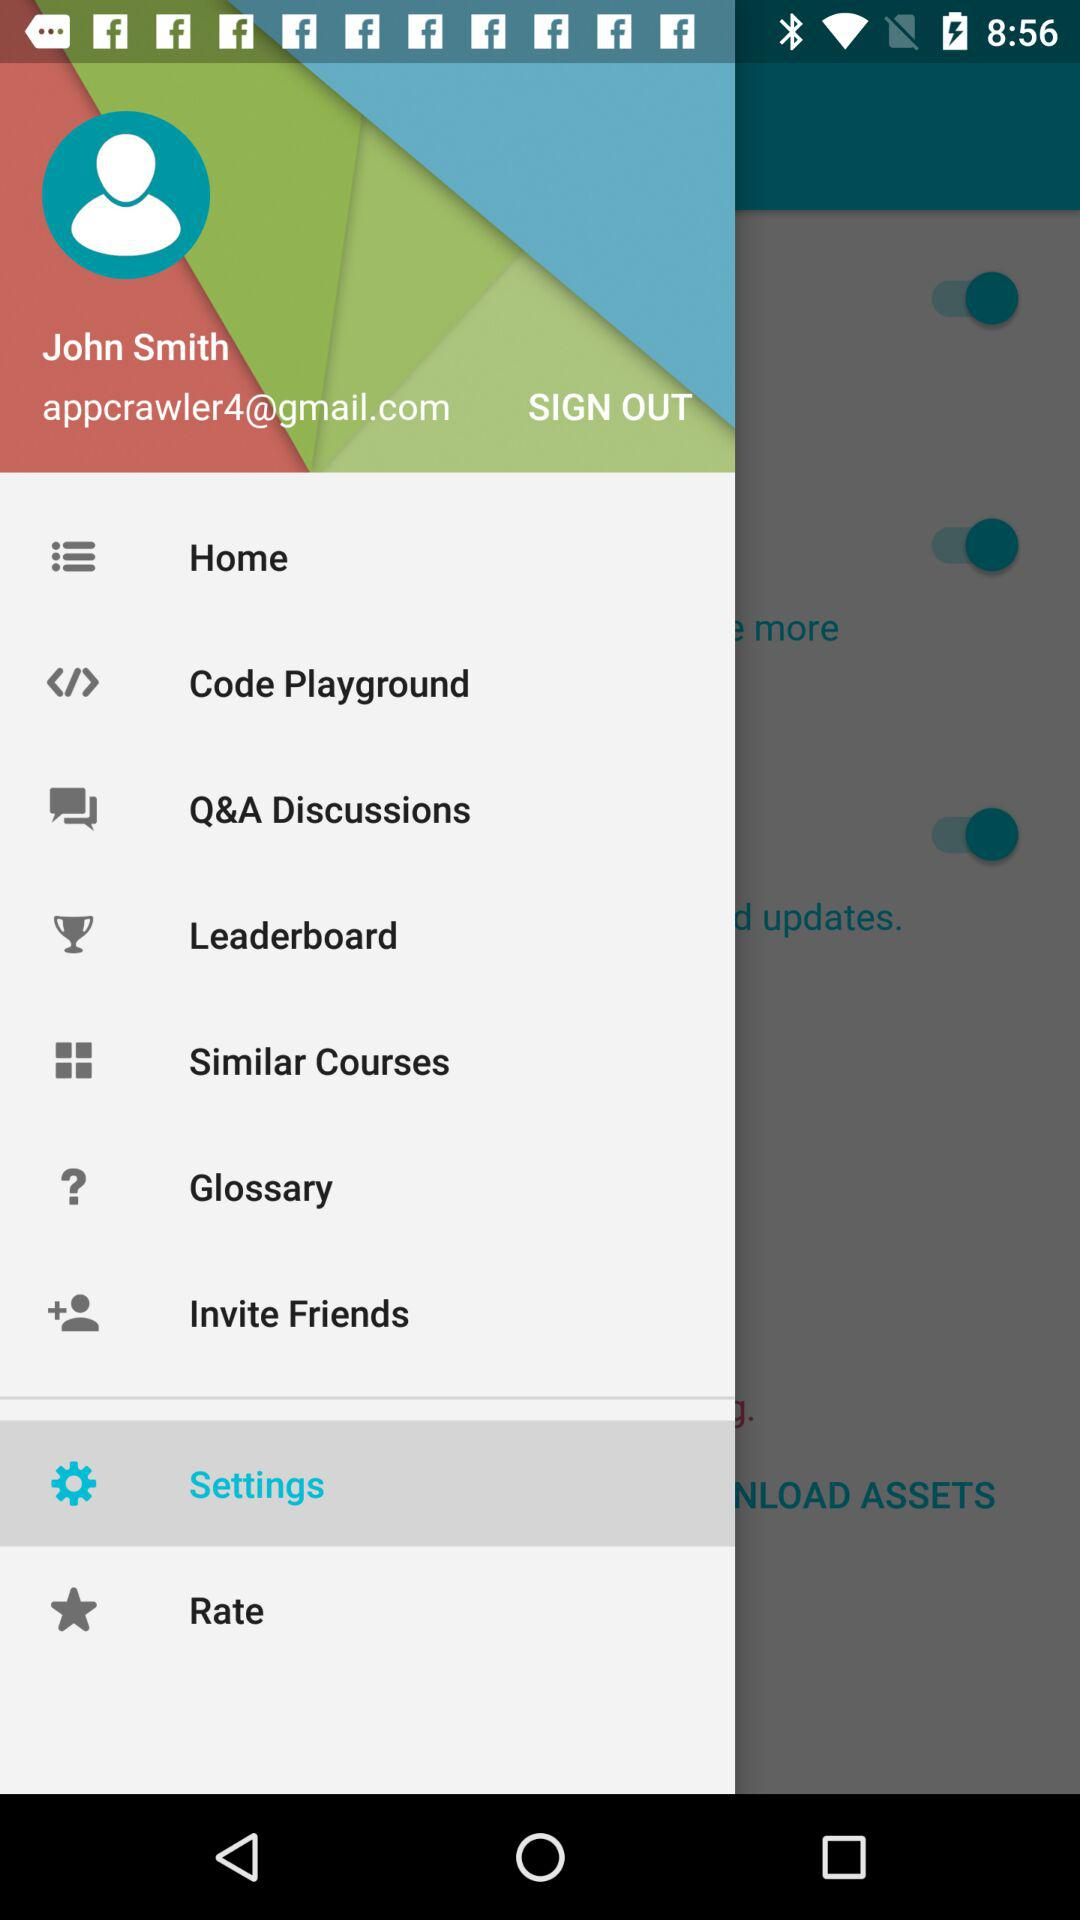What is the email address? The email address is appcrawler4@gmail.com. 